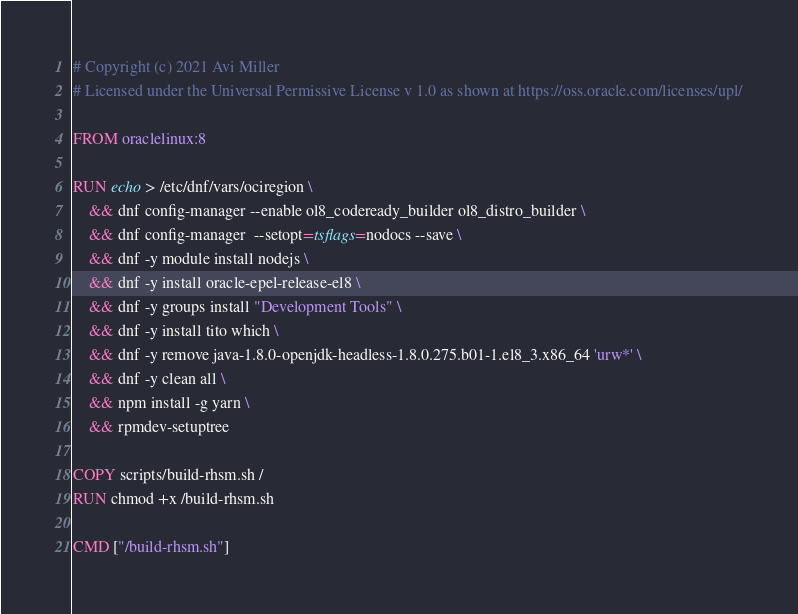Convert code to text. <code><loc_0><loc_0><loc_500><loc_500><_Dockerfile_># Copyright (c) 2021 Avi Miller
# Licensed under the Universal Permissive License v 1.0 as shown at https://oss.oracle.com/licenses/upl/

FROM oraclelinux:8

RUN echo > /etc/dnf/vars/ociregion \
    && dnf config-manager --enable ol8_codeready_builder ol8_distro_builder \
    && dnf config-manager  --setopt=tsflags=nodocs --save \
    && dnf -y module install nodejs \
    && dnf -y install oracle-epel-release-el8 \
    && dnf -y groups install "Development Tools" \
    && dnf -y install tito which \
    && dnf -y remove java-1.8.0-openjdk-headless-1.8.0.275.b01-1.el8_3.x86_64 'urw*' \
    && dnf -y clean all \
    && npm install -g yarn \
    && rpmdev-setuptree

COPY scripts/build-rhsm.sh /
RUN chmod +x /build-rhsm.sh

CMD ["/build-rhsm.sh"]
</code> 